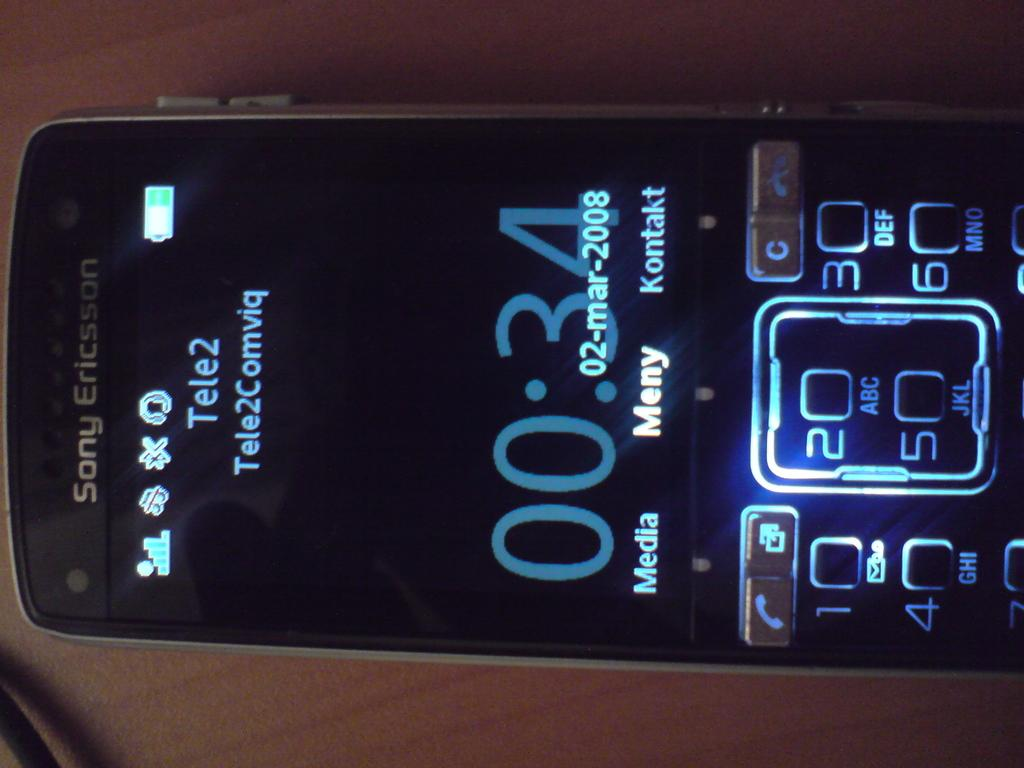<image>
Relay a brief, clear account of the picture shown. A Sony Ericsson phone has a tele2 provider at 00.34 am. 